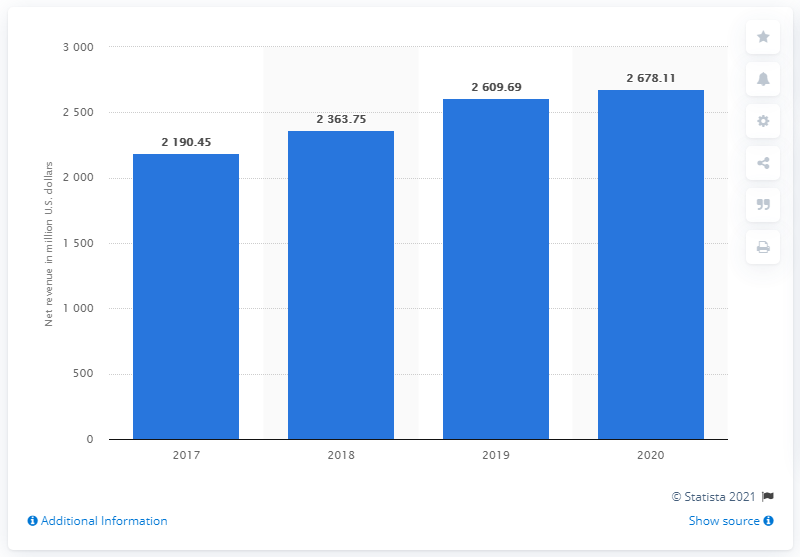Point out several critical features in this image. The company's net revenue in 2020 was 2678.11. In 2019, the company's net revenue was 2,609.69. 